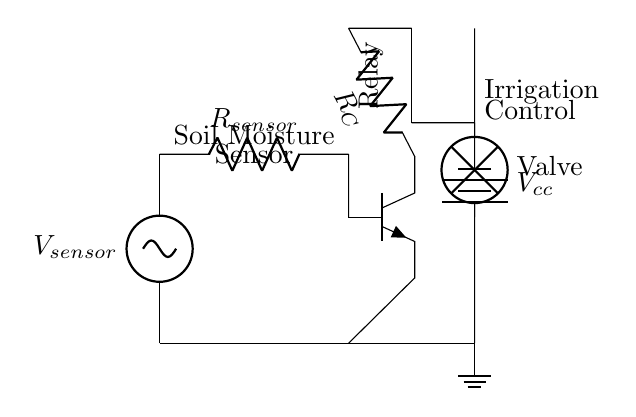What is the role of the sensor in the circuit? The sensor detects soil moisture levels and influences the operation of the transistor based on moisture conditions.
Answer: Soil moisture detection What component controls the irrigation valve? The relay plays a crucial role by acting as a switch that hands off control from the transistor to the valve for irrigation purposes.
Answer: Relay What is the voltage supplied to the circuit? The circuit has a voltage supply of five volts, which is labeled next to the power supply in the diagram.
Answer: 5V How many resistors are present in the circuit? There are two resistors present: one in series with the soil moisture sensor and another for the transistor collector.
Answer: 2 What is the purpose of the transistor in this circuit? The transistor functions as a switch that controls the relay, which in turn regulates the irrigation valve based on the sensor readings.
Answer: Switch What happens when the soil is dry? When the soil is dry, the sensor output reduces, causing the transistor to switch off, thus deactivating the relay and closing the irrigation valve.
Answer: Valve closes What type of transistor is used in this circuit? The circuit employs an NPN transistor, as indicated by its symbol in the diagram.
Answer: NPN 